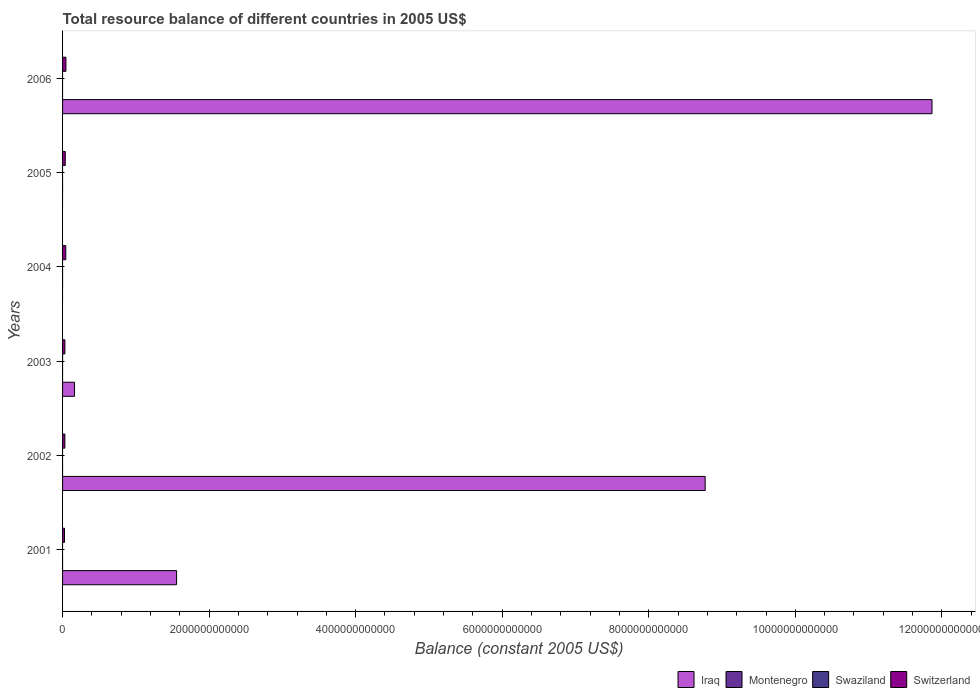Are the number of bars on each tick of the Y-axis equal?
Offer a very short reply. No. How many bars are there on the 1st tick from the bottom?
Your answer should be very brief. 2. What is the label of the 6th group of bars from the top?
Provide a succinct answer. 2001. In how many cases, is the number of bars for a given year not equal to the number of legend labels?
Keep it short and to the point. 6. What is the total resource balance in Iraq in 2006?
Provide a succinct answer. 1.19e+13. Across all years, what is the maximum total resource balance in Switzerland?
Offer a terse response. 4.57e+1. What is the total total resource balance in Iraq in the graph?
Keep it short and to the point. 2.24e+13. What is the difference between the total resource balance in Switzerland in 2005 and that in 2006?
Offer a terse response. -8.83e+09. What is the difference between the total resource balance in Switzerland in 2005 and the total resource balance in Montenegro in 2001?
Provide a short and direct response. 3.69e+1. What is the average total resource balance in Switzerland per year?
Offer a very short reply. 3.60e+1. In the year 2006, what is the difference between the total resource balance in Iraq and total resource balance in Switzerland?
Ensure brevity in your answer.  1.18e+13. In how many years, is the total resource balance in Montenegro greater than 400000000000 US$?
Provide a short and direct response. 0. What is the ratio of the total resource balance in Switzerland in 2001 to that in 2004?
Provide a short and direct response. 0.6. Is the difference between the total resource balance in Iraq in 2002 and 2003 greater than the difference between the total resource balance in Switzerland in 2002 and 2003?
Give a very brief answer. Yes. What is the difference between the highest and the second highest total resource balance in Iraq?
Provide a succinct answer. 3.10e+12. What is the difference between the highest and the lowest total resource balance in Iraq?
Make the answer very short. 1.19e+13. In how many years, is the total resource balance in Switzerland greater than the average total resource balance in Switzerland taken over all years?
Keep it short and to the point. 3. Is the sum of the total resource balance in Switzerland in 2003 and 2004 greater than the maximum total resource balance in Montenegro across all years?
Offer a terse response. Yes. Is it the case that in every year, the sum of the total resource balance in Swaziland and total resource balance in Montenegro is greater than the sum of total resource balance in Switzerland and total resource balance in Iraq?
Ensure brevity in your answer.  No. How many years are there in the graph?
Your answer should be compact. 6. What is the difference between two consecutive major ticks on the X-axis?
Your answer should be compact. 2.00e+12. Are the values on the major ticks of X-axis written in scientific E-notation?
Give a very brief answer. No. Where does the legend appear in the graph?
Keep it short and to the point. Bottom right. How many legend labels are there?
Provide a short and direct response. 4. How are the legend labels stacked?
Provide a succinct answer. Horizontal. What is the title of the graph?
Your answer should be very brief. Total resource balance of different countries in 2005 US$. What is the label or title of the X-axis?
Provide a succinct answer. Balance (constant 2005 US$). What is the label or title of the Y-axis?
Provide a succinct answer. Years. What is the Balance (constant 2005 US$) of Iraq in 2001?
Keep it short and to the point. 1.56e+12. What is the Balance (constant 2005 US$) of Montenegro in 2001?
Your response must be concise. 0. What is the Balance (constant 2005 US$) in Switzerland in 2001?
Your answer should be compact. 2.64e+1. What is the Balance (constant 2005 US$) in Iraq in 2002?
Your response must be concise. 8.77e+12. What is the Balance (constant 2005 US$) in Swaziland in 2002?
Make the answer very short. 0. What is the Balance (constant 2005 US$) in Switzerland in 2002?
Offer a very short reply. 3.16e+1. What is the Balance (constant 2005 US$) of Iraq in 2003?
Offer a very short reply. 1.63e+11. What is the Balance (constant 2005 US$) in Switzerland in 2003?
Provide a succinct answer. 3.18e+1. What is the Balance (constant 2005 US$) in Iraq in 2004?
Provide a short and direct response. 0. What is the Balance (constant 2005 US$) of Swaziland in 2004?
Ensure brevity in your answer.  0. What is the Balance (constant 2005 US$) in Switzerland in 2004?
Provide a succinct answer. 4.39e+1. What is the Balance (constant 2005 US$) in Iraq in 2005?
Provide a succinct answer. 0. What is the Balance (constant 2005 US$) of Montenegro in 2005?
Your answer should be compact. 0. What is the Balance (constant 2005 US$) in Swaziland in 2005?
Offer a terse response. 0. What is the Balance (constant 2005 US$) in Switzerland in 2005?
Your answer should be very brief. 3.69e+1. What is the Balance (constant 2005 US$) in Iraq in 2006?
Provide a short and direct response. 1.19e+13. What is the Balance (constant 2005 US$) of Montenegro in 2006?
Provide a short and direct response. 0. What is the Balance (constant 2005 US$) of Swaziland in 2006?
Keep it short and to the point. 0. What is the Balance (constant 2005 US$) in Switzerland in 2006?
Your answer should be compact. 4.57e+1. Across all years, what is the maximum Balance (constant 2005 US$) in Iraq?
Provide a short and direct response. 1.19e+13. Across all years, what is the maximum Balance (constant 2005 US$) of Switzerland?
Give a very brief answer. 4.57e+1. Across all years, what is the minimum Balance (constant 2005 US$) in Switzerland?
Offer a terse response. 2.64e+1. What is the total Balance (constant 2005 US$) of Iraq in the graph?
Provide a succinct answer. 2.24e+13. What is the total Balance (constant 2005 US$) of Switzerland in the graph?
Your response must be concise. 2.16e+11. What is the difference between the Balance (constant 2005 US$) in Iraq in 2001 and that in 2002?
Your answer should be very brief. -7.21e+12. What is the difference between the Balance (constant 2005 US$) in Switzerland in 2001 and that in 2002?
Give a very brief answer. -5.17e+09. What is the difference between the Balance (constant 2005 US$) of Iraq in 2001 and that in 2003?
Provide a short and direct response. 1.39e+12. What is the difference between the Balance (constant 2005 US$) in Switzerland in 2001 and that in 2003?
Offer a very short reply. -5.36e+09. What is the difference between the Balance (constant 2005 US$) in Switzerland in 2001 and that in 2004?
Keep it short and to the point. -1.75e+1. What is the difference between the Balance (constant 2005 US$) in Switzerland in 2001 and that in 2005?
Your answer should be very brief. -1.05e+1. What is the difference between the Balance (constant 2005 US$) in Iraq in 2001 and that in 2006?
Keep it short and to the point. -1.03e+13. What is the difference between the Balance (constant 2005 US$) of Switzerland in 2001 and that in 2006?
Ensure brevity in your answer.  -1.93e+1. What is the difference between the Balance (constant 2005 US$) in Iraq in 2002 and that in 2003?
Make the answer very short. 8.61e+12. What is the difference between the Balance (constant 2005 US$) of Switzerland in 2002 and that in 2003?
Keep it short and to the point. -1.92e+08. What is the difference between the Balance (constant 2005 US$) of Switzerland in 2002 and that in 2004?
Your answer should be very brief. -1.23e+1. What is the difference between the Balance (constant 2005 US$) of Switzerland in 2002 and that in 2005?
Provide a succinct answer. -5.33e+09. What is the difference between the Balance (constant 2005 US$) of Iraq in 2002 and that in 2006?
Your answer should be very brief. -3.10e+12. What is the difference between the Balance (constant 2005 US$) in Switzerland in 2002 and that in 2006?
Make the answer very short. -1.42e+1. What is the difference between the Balance (constant 2005 US$) of Switzerland in 2003 and that in 2004?
Offer a terse response. -1.21e+1. What is the difference between the Balance (constant 2005 US$) in Switzerland in 2003 and that in 2005?
Provide a succinct answer. -5.14e+09. What is the difference between the Balance (constant 2005 US$) in Iraq in 2003 and that in 2006?
Offer a terse response. -1.17e+13. What is the difference between the Balance (constant 2005 US$) of Switzerland in 2003 and that in 2006?
Ensure brevity in your answer.  -1.40e+1. What is the difference between the Balance (constant 2005 US$) of Switzerland in 2004 and that in 2005?
Offer a very short reply. 6.96e+09. What is the difference between the Balance (constant 2005 US$) in Switzerland in 2004 and that in 2006?
Give a very brief answer. -1.87e+09. What is the difference between the Balance (constant 2005 US$) in Switzerland in 2005 and that in 2006?
Provide a short and direct response. -8.83e+09. What is the difference between the Balance (constant 2005 US$) in Iraq in 2001 and the Balance (constant 2005 US$) in Switzerland in 2002?
Your response must be concise. 1.52e+12. What is the difference between the Balance (constant 2005 US$) in Iraq in 2001 and the Balance (constant 2005 US$) in Switzerland in 2003?
Your answer should be compact. 1.52e+12. What is the difference between the Balance (constant 2005 US$) in Iraq in 2001 and the Balance (constant 2005 US$) in Switzerland in 2004?
Provide a short and direct response. 1.51e+12. What is the difference between the Balance (constant 2005 US$) of Iraq in 2001 and the Balance (constant 2005 US$) of Switzerland in 2005?
Provide a succinct answer. 1.52e+12. What is the difference between the Balance (constant 2005 US$) of Iraq in 2001 and the Balance (constant 2005 US$) of Switzerland in 2006?
Offer a terse response. 1.51e+12. What is the difference between the Balance (constant 2005 US$) of Iraq in 2002 and the Balance (constant 2005 US$) of Switzerland in 2003?
Provide a short and direct response. 8.74e+12. What is the difference between the Balance (constant 2005 US$) in Iraq in 2002 and the Balance (constant 2005 US$) in Switzerland in 2004?
Your response must be concise. 8.73e+12. What is the difference between the Balance (constant 2005 US$) of Iraq in 2002 and the Balance (constant 2005 US$) of Switzerland in 2005?
Give a very brief answer. 8.73e+12. What is the difference between the Balance (constant 2005 US$) of Iraq in 2002 and the Balance (constant 2005 US$) of Switzerland in 2006?
Your answer should be compact. 8.72e+12. What is the difference between the Balance (constant 2005 US$) in Iraq in 2003 and the Balance (constant 2005 US$) in Switzerland in 2004?
Give a very brief answer. 1.19e+11. What is the difference between the Balance (constant 2005 US$) in Iraq in 2003 and the Balance (constant 2005 US$) in Switzerland in 2005?
Your answer should be compact. 1.26e+11. What is the difference between the Balance (constant 2005 US$) in Iraq in 2003 and the Balance (constant 2005 US$) in Switzerland in 2006?
Make the answer very short. 1.17e+11. What is the average Balance (constant 2005 US$) of Iraq per year?
Give a very brief answer. 3.73e+12. What is the average Balance (constant 2005 US$) in Montenegro per year?
Make the answer very short. 0. What is the average Balance (constant 2005 US$) in Swaziland per year?
Your answer should be compact. 0. What is the average Balance (constant 2005 US$) in Switzerland per year?
Give a very brief answer. 3.60e+1. In the year 2001, what is the difference between the Balance (constant 2005 US$) in Iraq and Balance (constant 2005 US$) in Switzerland?
Offer a very short reply. 1.53e+12. In the year 2002, what is the difference between the Balance (constant 2005 US$) of Iraq and Balance (constant 2005 US$) of Switzerland?
Your answer should be compact. 8.74e+12. In the year 2003, what is the difference between the Balance (constant 2005 US$) of Iraq and Balance (constant 2005 US$) of Switzerland?
Your answer should be very brief. 1.31e+11. In the year 2006, what is the difference between the Balance (constant 2005 US$) in Iraq and Balance (constant 2005 US$) in Switzerland?
Keep it short and to the point. 1.18e+13. What is the ratio of the Balance (constant 2005 US$) of Iraq in 2001 to that in 2002?
Your answer should be very brief. 0.18. What is the ratio of the Balance (constant 2005 US$) in Switzerland in 2001 to that in 2002?
Offer a terse response. 0.84. What is the ratio of the Balance (constant 2005 US$) in Iraq in 2001 to that in 2003?
Your response must be concise. 9.55. What is the ratio of the Balance (constant 2005 US$) in Switzerland in 2001 to that in 2003?
Give a very brief answer. 0.83. What is the ratio of the Balance (constant 2005 US$) in Switzerland in 2001 to that in 2004?
Offer a very short reply. 0.6. What is the ratio of the Balance (constant 2005 US$) of Switzerland in 2001 to that in 2005?
Your answer should be very brief. 0.72. What is the ratio of the Balance (constant 2005 US$) in Iraq in 2001 to that in 2006?
Provide a short and direct response. 0.13. What is the ratio of the Balance (constant 2005 US$) of Switzerland in 2001 to that in 2006?
Provide a short and direct response. 0.58. What is the ratio of the Balance (constant 2005 US$) in Iraq in 2002 to that in 2003?
Your response must be concise. 53.81. What is the ratio of the Balance (constant 2005 US$) of Switzerland in 2002 to that in 2004?
Your answer should be very brief. 0.72. What is the ratio of the Balance (constant 2005 US$) of Switzerland in 2002 to that in 2005?
Make the answer very short. 0.86. What is the ratio of the Balance (constant 2005 US$) in Iraq in 2002 to that in 2006?
Offer a very short reply. 0.74. What is the ratio of the Balance (constant 2005 US$) in Switzerland in 2002 to that in 2006?
Offer a very short reply. 0.69. What is the ratio of the Balance (constant 2005 US$) in Switzerland in 2003 to that in 2004?
Provide a succinct answer. 0.72. What is the ratio of the Balance (constant 2005 US$) in Switzerland in 2003 to that in 2005?
Offer a very short reply. 0.86. What is the ratio of the Balance (constant 2005 US$) in Iraq in 2003 to that in 2006?
Keep it short and to the point. 0.01. What is the ratio of the Balance (constant 2005 US$) of Switzerland in 2003 to that in 2006?
Your answer should be very brief. 0.69. What is the ratio of the Balance (constant 2005 US$) in Switzerland in 2004 to that in 2005?
Keep it short and to the point. 1.19. What is the ratio of the Balance (constant 2005 US$) of Switzerland in 2004 to that in 2006?
Make the answer very short. 0.96. What is the ratio of the Balance (constant 2005 US$) in Switzerland in 2005 to that in 2006?
Offer a very short reply. 0.81. What is the difference between the highest and the second highest Balance (constant 2005 US$) in Iraq?
Make the answer very short. 3.10e+12. What is the difference between the highest and the second highest Balance (constant 2005 US$) in Switzerland?
Your response must be concise. 1.87e+09. What is the difference between the highest and the lowest Balance (constant 2005 US$) of Iraq?
Provide a succinct answer. 1.19e+13. What is the difference between the highest and the lowest Balance (constant 2005 US$) in Switzerland?
Your answer should be very brief. 1.93e+1. 